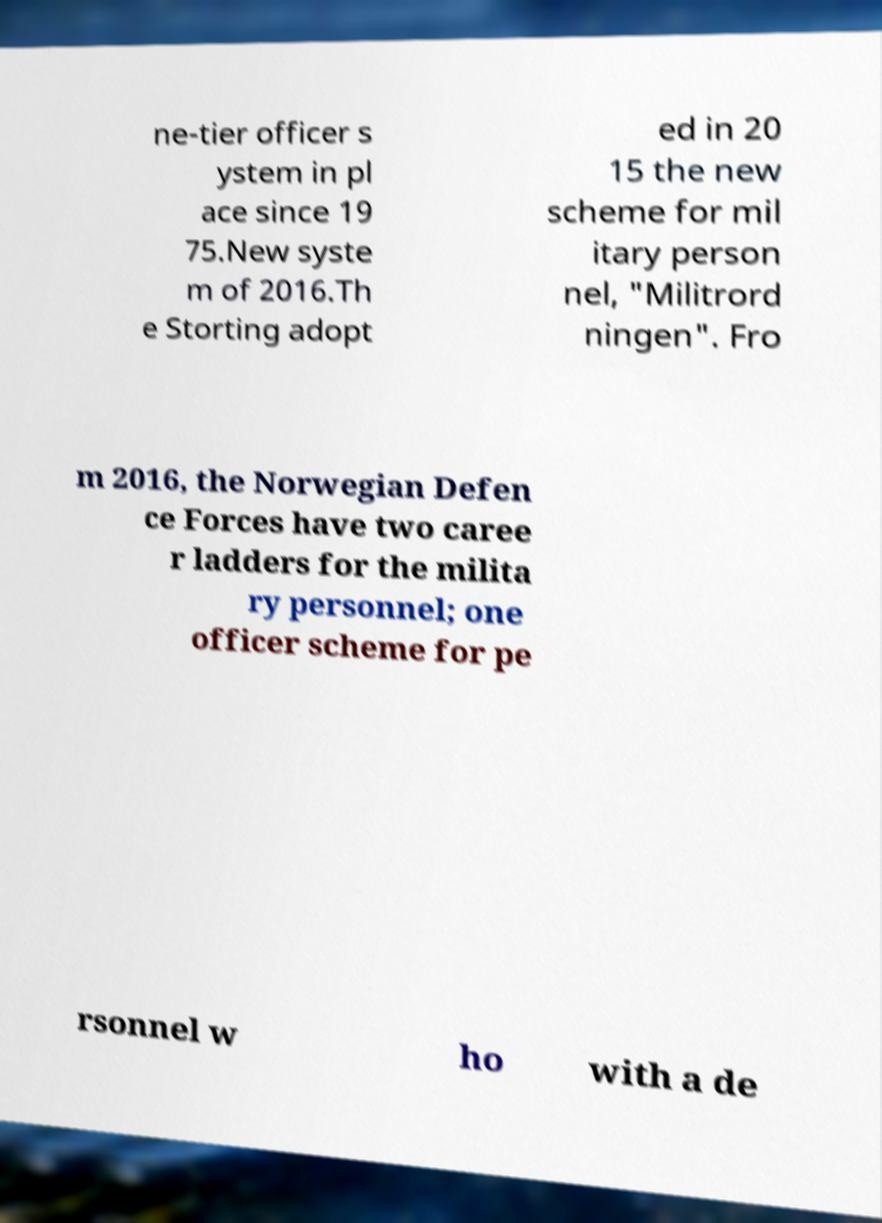Please identify and transcribe the text found in this image. ne-tier officer s ystem in pl ace since 19 75.New syste m of 2016.Th e Storting adopt ed in 20 15 the new scheme for mil itary person nel, "Militrord ningen". Fro m 2016, the Norwegian Defen ce Forces have two caree r ladders for the milita ry personnel; one officer scheme for pe rsonnel w ho with a de 